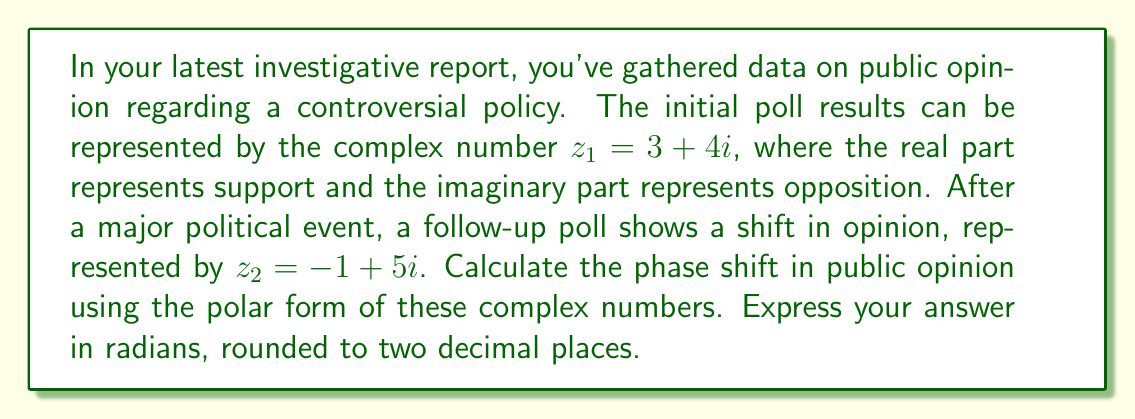Provide a solution to this math problem. To calculate the phase shift, we need to follow these steps:

1) Convert both complex numbers to polar form:
   $z = r(\cos\theta + i\sin\theta) = re^{i\theta}$

2) For $z_1 = 3 + 4i$:
   $r_1 = \sqrt{3^2 + 4^2} = 5$
   $\theta_1 = \arctan(\frac{4}{3}) \approx 0.93$ radians

3) For $z_2 = -1 + 5i$:
   $r_2 = \sqrt{(-1)^2 + 5^2} = \sqrt{26}$
   $\theta_2 = \arctan(\frac{5}{-1}) + \pi \approx 2.68$ radians
   (We add $\pi$ because the angle is in the second quadrant)

4) The phase shift is the difference between these angles:
   $\Delta\theta = \theta_2 - \theta_1 = 2.68 - 0.93 = 1.75$ radians

5) Rounding to two decimal places: 1.75 radians

This phase shift represents the change in the balance of public opinion after the political event.
Answer: 1.75 radians 